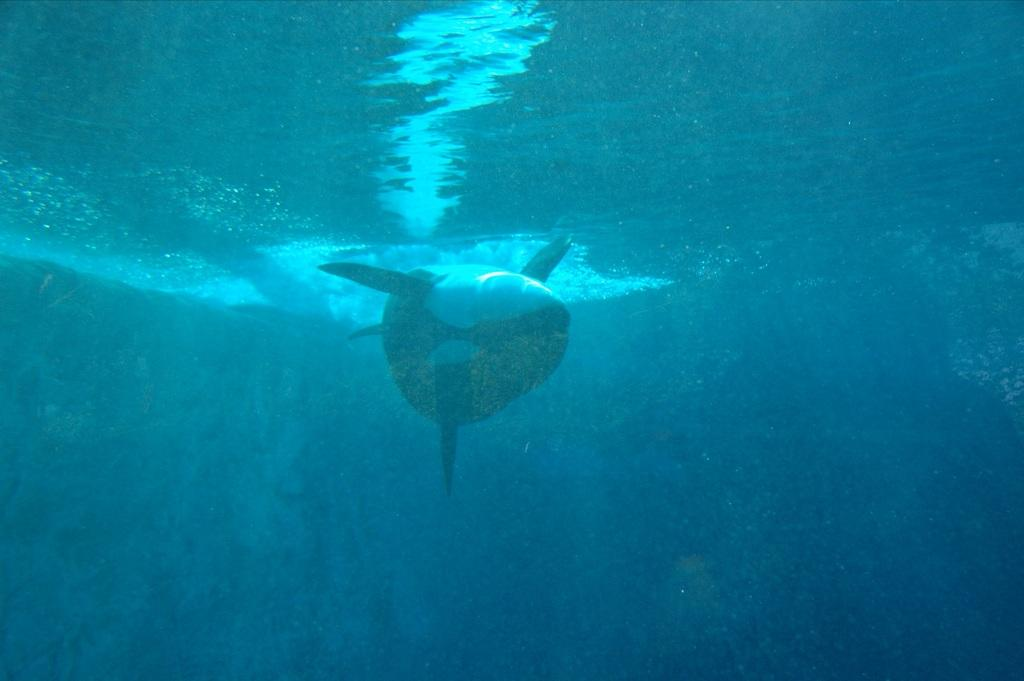What type of animal is in the foreground of the image? There is an aquatic animal in the foreground of the image. Where is the aquatic animal located in relation to the water? The aquatic animal is under the water. What type of cap is the achiever wearing in the image? There is no achiever or cap present in the image; it features an aquatic animal underwater. 